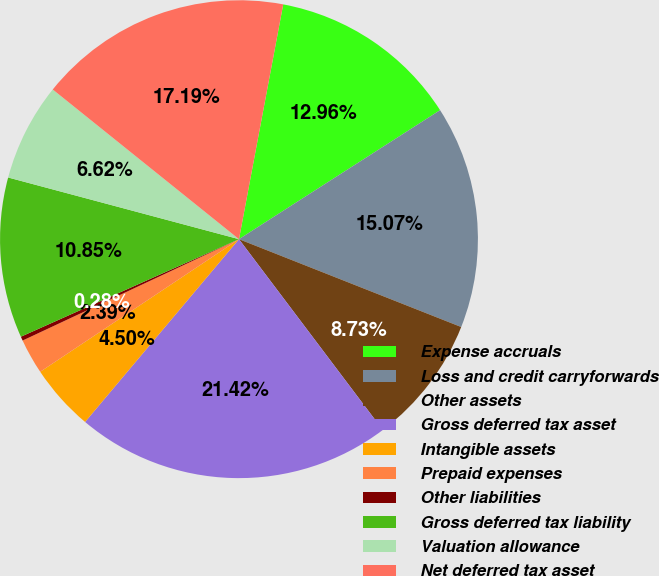<chart> <loc_0><loc_0><loc_500><loc_500><pie_chart><fcel>Expense accruals<fcel>Loss and credit carryforwards<fcel>Other assets<fcel>Gross deferred tax asset<fcel>Intangible assets<fcel>Prepaid expenses<fcel>Other liabilities<fcel>Gross deferred tax liability<fcel>Valuation allowance<fcel>Net deferred tax asset<nl><fcel>12.96%<fcel>15.07%<fcel>8.73%<fcel>21.42%<fcel>4.5%<fcel>2.39%<fcel>0.28%<fcel>10.85%<fcel>6.62%<fcel>17.19%<nl></chart> 